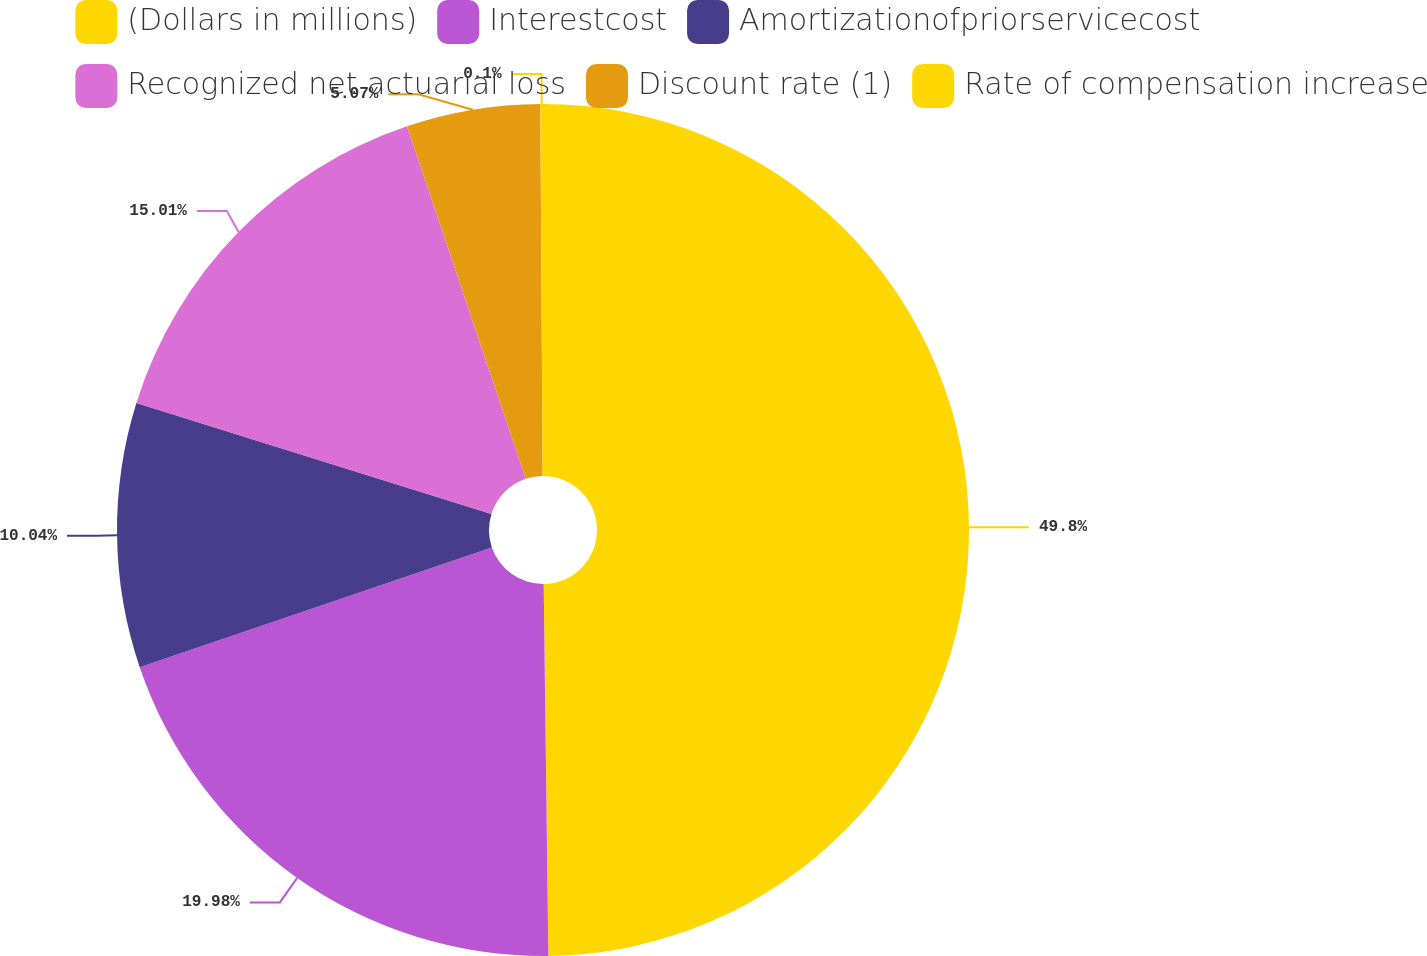Convert chart. <chart><loc_0><loc_0><loc_500><loc_500><pie_chart><fcel>(Dollars in millions)<fcel>Interestcost<fcel>Amortizationofpriorservicecost<fcel>Recognized net actuarial loss<fcel>Discount rate (1)<fcel>Rate of compensation increase<nl><fcel>49.8%<fcel>19.98%<fcel>10.04%<fcel>15.01%<fcel>5.07%<fcel>0.1%<nl></chart> 